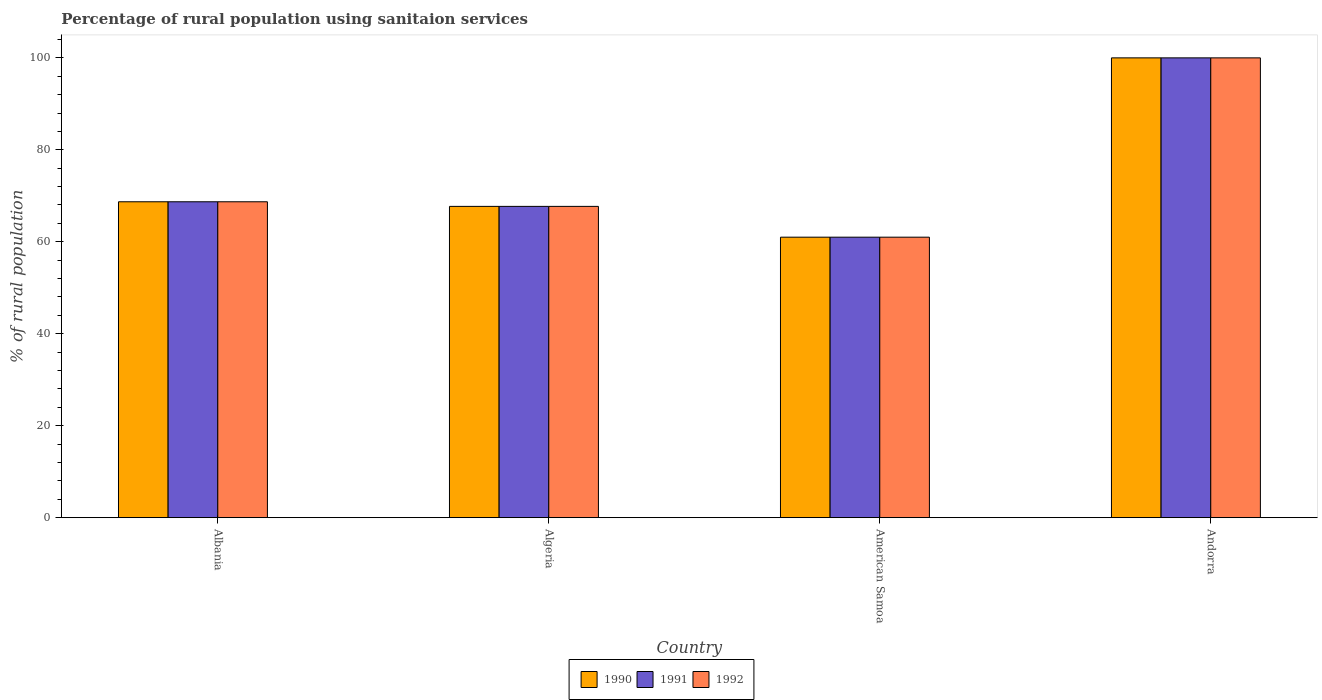Are the number of bars per tick equal to the number of legend labels?
Your answer should be very brief. Yes. Are the number of bars on each tick of the X-axis equal?
Your answer should be very brief. Yes. How many bars are there on the 1st tick from the left?
Keep it short and to the point. 3. How many bars are there on the 1st tick from the right?
Offer a very short reply. 3. What is the label of the 2nd group of bars from the left?
Make the answer very short. Algeria. In how many cases, is the number of bars for a given country not equal to the number of legend labels?
Your answer should be very brief. 0. What is the percentage of rural population using sanitaion services in 1991 in American Samoa?
Give a very brief answer. 61. In which country was the percentage of rural population using sanitaion services in 1992 maximum?
Provide a short and direct response. Andorra. In which country was the percentage of rural population using sanitaion services in 1992 minimum?
Provide a short and direct response. American Samoa. What is the total percentage of rural population using sanitaion services in 1992 in the graph?
Make the answer very short. 297.4. What is the difference between the percentage of rural population using sanitaion services in 1992 in Albania and that in Andorra?
Provide a short and direct response. -31.3. What is the difference between the percentage of rural population using sanitaion services in 1990 in Andorra and the percentage of rural population using sanitaion services in 1991 in Algeria?
Give a very brief answer. 32.3. What is the average percentage of rural population using sanitaion services in 1992 per country?
Ensure brevity in your answer.  74.35. In how many countries, is the percentage of rural population using sanitaion services in 1992 greater than 68 %?
Make the answer very short. 2. What is the ratio of the percentage of rural population using sanitaion services in 1991 in Albania to that in Andorra?
Provide a succinct answer. 0.69. Is the percentage of rural population using sanitaion services in 1990 in Albania less than that in American Samoa?
Provide a short and direct response. No. Is the difference between the percentage of rural population using sanitaion services in 1992 in Algeria and Andorra greater than the difference between the percentage of rural population using sanitaion services in 1990 in Algeria and Andorra?
Ensure brevity in your answer.  No. What is the difference between the highest and the second highest percentage of rural population using sanitaion services in 1990?
Offer a very short reply. -32.3. What is the difference between the highest and the lowest percentage of rural population using sanitaion services in 1991?
Keep it short and to the point. 39. What does the 1st bar from the left in Algeria represents?
Give a very brief answer. 1990. What does the 1st bar from the right in Albania represents?
Provide a succinct answer. 1992. Is it the case that in every country, the sum of the percentage of rural population using sanitaion services in 1992 and percentage of rural population using sanitaion services in 1991 is greater than the percentage of rural population using sanitaion services in 1990?
Keep it short and to the point. Yes. How many bars are there?
Your answer should be compact. 12. Are all the bars in the graph horizontal?
Offer a very short reply. No. How many countries are there in the graph?
Offer a very short reply. 4. What is the difference between two consecutive major ticks on the Y-axis?
Make the answer very short. 20. Does the graph contain any zero values?
Provide a short and direct response. No. Where does the legend appear in the graph?
Your answer should be compact. Bottom center. How many legend labels are there?
Offer a terse response. 3. How are the legend labels stacked?
Provide a short and direct response. Horizontal. What is the title of the graph?
Give a very brief answer. Percentage of rural population using sanitaion services. What is the label or title of the Y-axis?
Your answer should be compact. % of rural population. What is the % of rural population in 1990 in Albania?
Offer a terse response. 68.7. What is the % of rural population in 1991 in Albania?
Keep it short and to the point. 68.7. What is the % of rural population of 1992 in Albania?
Your response must be concise. 68.7. What is the % of rural population of 1990 in Algeria?
Your answer should be very brief. 67.7. What is the % of rural population in 1991 in Algeria?
Make the answer very short. 67.7. What is the % of rural population of 1992 in Algeria?
Provide a short and direct response. 67.7. What is the % of rural population in 1991 in Andorra?
Keep it short and to the point. 100. What is the % of rural population of 1992 in Andorra?
Offer a very short reply. 100. Across all countries, what is the maximum % of rural population in 1990?
Your response must be concise. 100. Across all countries, what is the maximum % of rural population in 1992?
Offer a terse response. 100. Across all countries, what is the minimum % of rural population of 1990?
Offer a terse response. 61. Across all countries, what is the minimum % of rural population in 1991?
Your response must be concise. 61. What is the total % of rural population of 1990 in the graph?
Make the answer very short. 297.4. What is the total % of rural population in 1991 in the graph?
Provide a short and direct response. 297.4. What is the total % of rural population of 1992 in the graph?
Your answer should be very brief. 297.4. What is the difference between the % of rural population in 1992 in Albania and that in American Samoa?
Make the answer very short. 7.7. What is the difference between the % of rural population of 1990 in Albania and that in Andorra?
Your response must be concise. -31.3. What is the difference between the % of rural population in 1991 in Albania and that in Andorra?
Offer a terse response. -31.3. What is the difference between the % of rural population of 1992 in Albania and that in Andorra?
Offer a very short reply. -31.3. What is the difference between the % of rural population of 1991 in Algeria and that in American Samoa?
Ensure brevity in your answer.  6.7. What is the difference between the % of rural population of 1990 in Algeria and that in Andorra?
Provide a short and direct response. -32.3. What is the difference between the % of rural population of 1991 in Algeria and that in Andorra?
Offer a terse response. -32.3. What is the difference between the % of rural population in 1992 in Algeria and that in Andorra?
Make the answer very short. -32.3. What is the difference between the % of rural population of 1990 in American Samoa and that in Andorra?
Offer a terse response. -39. What is the difference between the % of rural population in 1991 in American Samoa and that in Andorra?
Offer a terse response. -39. What is the difference between the % of rural population in 1992 in American Samoa and that in Andorra?
Your response must be concise. -39. What is the difference between the % of rural population of 1990 in Albania and the % of rural population of 1991 in Algeria?
Ensure brevity in your answer.  1. What is the difference between the % of rural population in 1990 in Albania and the % of rural population in 1991 in American Samoa?
Provide a short and direct response. 7.7. What is the difference between the % of rural population in 1991 in Albania and the % of rural population in 1992 in American Samoa?
Give a very brief answer. 7.7. What is the difference between the % of rural population of 1990 in Albania and the % of rural population of 1991 in Andorra?
Give a very brief answer. -31.3. What is the difference between the % of rural population in 1990 in Albania and the % of rural population in 1992 in Andorra?
Your answer should be very brief. -31.3. What is the difference between the % of rural population in 1991 in Albania and the % of rural population in 1992 in Andorra?
Ensure brevity in your answer.  -31.3. What is the difference between the % of rural population of 1990 in Algeria and the % of rural population of 1991 in American Samoa?
Make the answer very short. 6.7. What is the difference between the % of rural population in 1990 in Algeria and the % of rural population in 1992 in American Samoa?
Offer a very short reply. 6.7. What is the difference between the % of rural population of 1990 in Algeria and the % of rural population of 1991 in Andorra?
Your answer should be compact. -32.3. What is the difference between the % of rural population in 1990 in Algeria and the % of rural population in 1992 in Andorra?
Your response must be concise. -32.3. What is the difference between the % of rural population in 1991 in Algeria and the % of rural population in 1992 in Andorra?
Your answer should be compact. -32.3. What is the difference between the % of rural population of 1990 in American Samoa and the % of rural population of 1991 in Andorra?
Offer a very short reply. -39. What is the difference between the % of rural population of 1990 in American Samoa and the % of rural population of 1992 in Andorra?
Offer a terse response. -39. What is the difference between the % of rural population of 1991 in American Samoa and the % of rural population of 1992 in Andorra?
Ensure brevity in your answer.  -39. What is the average % of rural population of 1990 per country?
Make the answer very short. 74.35. What is the average % of rural population of 1991 per country?
Your answer should be compact. 74.35. What is the average % of rural population in 1992 per country?
Offer a very short reply. 74.35. What is the difference between the % of rural population in 1990 and % of rural population in 1992 in Algeria?
Your answer should be compact. 0. What is the difference between the % of rural population of 1990 and % of rural population of 1991 in Andorra?
Keep it short and to the point. 0. What is the difference between the % of rural population in 1990 and % of rural population in 1992 in Andorra?
Your answer should be very brief. 0. What is the difference between the % of rural population of 1991 and % of rural population of 1992 in Andorra?
Keep it short and to the point. 0. What is the ratio of the % of rural population of 1990 in Albania to that in Algeria?
Provide a short and direct response. 1.01. What is the ratio of the % of rural population of 1991 in Albania to that in Algeria?
Your response must be concise. 1.01. What is the ratio of the % of rural population in 1992 in Albania to that in Algeria?
Your answer should be very brief. 1.01. What is the ratio of the % of rural population in 1990 in Albania to that in American Samoa?
Make the answer very short. 1.13. What is the ratio of the % of rural population of 1991 in Albania to that in American Samoa?
Offer a terse response. 1.13. What is the ratio of the % of rural population in 1992 in Albania to that in American Samoa?
Your answer should be very brief. 1.13. What is the ratio of the % of rural population of 1990 in Albania to that in Andorra?
Offer a very short reply. 0.69. What is the ratio of the % of rural population in 1991 in Albania to that in Andorra?
Your answer should be very brief. 0.69. What is the ratio of the % of rural population in 1992 in Albania to that in Andorra?
Your response must be concise. 0.69. What is the ratio of the % of rural population in 1990 in Algeria to that in American Samoa?
Provide a succinct answer. 1.11. What is the ratio of the % of rural population of 1991 in Algeria to that in American Samoa?
Offer a terse response. 1.11. What is the ratio of the % of rural population of 1992 in Algeria to that in American Samoa?
Provide a succinct answer. 1.11. What is the ratio of the % of rural population of 1990 in Algeria to that in Andorra?
Make the answer very short. 0.68. What is the ratio of the % of rural population of 1991 in Algeria to that in Andorra?
Provide a succinct answer. 0.68. What is the ratio of the % of rural population of 1992 in Algeria to that in Andorra?
Provide a short and direct response. 0.68. What is the ratio of the % of rural population in 1990 in American Samoa to that in Andorra?
Offer a terse response. 0.61. What is the ratio of the % of rural population of 1991 in American Samoa to that in Andorra?
Keep it short and to the point. 0.61. What is the ratio of the % of rural population in 1992 in American Samoa to that in Andorra?
Your response must be concise. 0.61. What is the difference between the highest and the second highest % of rural population of 1990?
Keep it short and to the point. 31.3. What is the difference between the highest and the second highest % of rural population of 1991?
Provide a short and direct response. 31.3. What is the difference between the highest and the second highest % of rural population in 1992?
Ensure brevity in your answer.  31.3. 